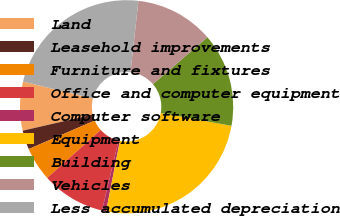Convert chart. <chart><loc_0><loc_0><loc_500><loc_500><pie_chart><fcel>Land<fcel>Leasehold improvements<fcel>Furniture and fixtures<fcel>Office and computer equipment<fcel>Computer software<fcel>Equipment<fcel>Building<fcel>Vehicles<fcel>Less accumulated depreciation<nl><fcel>7.4%<fcel>2.89%<fcel>5.14%<fcel>9.66%<fcel>0.63%<fcel>25.23%<fcel>14.17%<fcel>11.92%<fcel>22.97%<nl></chart> 